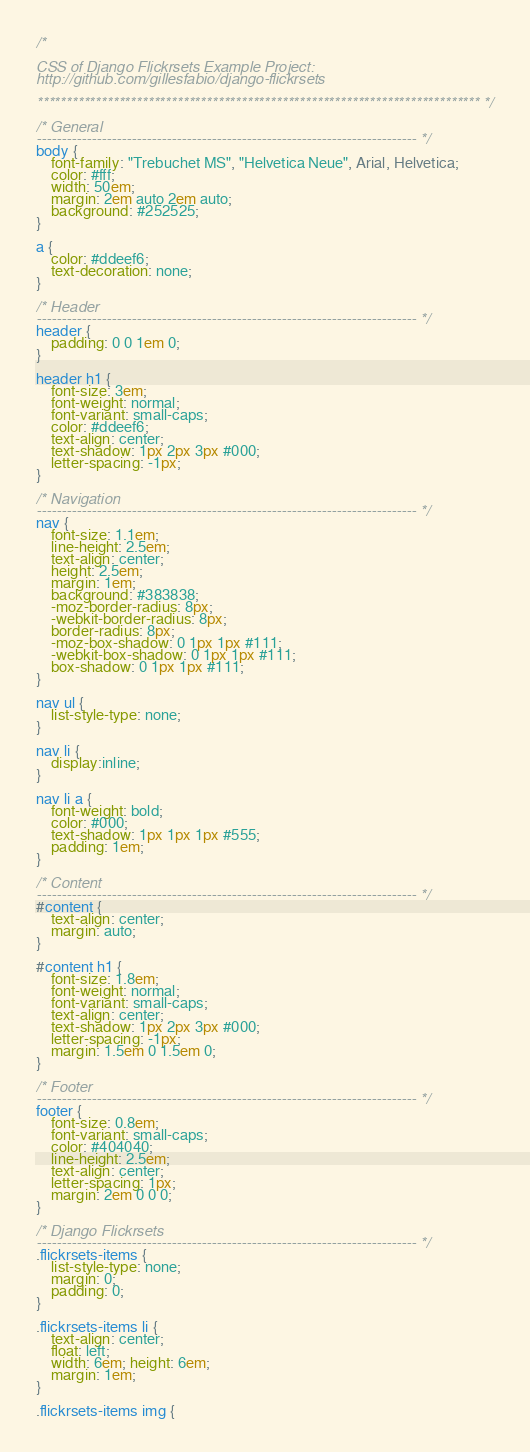<code> <loc_0><loc_0><loc_500><loc_500><_CSS_>/* 

CSS of Django Flickrsets Example Project: 
http://github.com/gillesfabio/django-flickrsets

**************************************************************************** */

/* General
---------------------------------------------------------------------------- */
body {
    font-family: "Trebuchet MS", "Helvetica Neue", Arial, Helvetica;
    color: #fff;
    width: 50em;
    margin: 2em auto 2em auto;
    background: #252525;
}

a { 
    color: #ddeef6; 
    text-decoration: none; 
}

/* Header
---------------------------------------------------------------------------- */
header { 
    padding: 0 0 1em 0; 
}

header h1 {
    font-size: 3em;
    font-weight: normal;
    font-variant: small-caps;
    color: #ddeef6;
    text-align: center;
    text-shadow: 1px 2px 3px #000;
    letter-spacing: -1px;
}

/* Navigation
---------------------------------------------------------------------------- */
nav {
    font-size: 1.1em;
    line-height: 2.5em;
    text-align: center;
    height: 2.5em;
    margin: 1em;
    background: #383838;
    -moz-border-radius: 8px;
    -webkit-border-radius: 8px;
    border-radius: 8px;
    -moz-box-shadow: 0 1px 1px #111;
    -webkit-box-shadow: 0 1px 1px #111;
    box-shadow: 0 1px 1px #111;
}

nav ul { 
    list-style-type: none; 
}

nav li { 
    display:inline; 
}

nav li a {
    font-weight: bold;
    color: #000;
    text-shadow: 1px 1px 1px #555;
    padding: 1em;
}

/* Content
---------------------------------------------------------------------------- */
#content { 
    text-align: center; 
    margin: auto; 
}

#content h1 {
    font-size: 1.8em;
    font-weight: normal;
    font-variant: small-caps;
    text-align: center;
    text-shadow: 1px 2px 3px #000;
    letter-spacing: -1px;
    margin: 1.5em 0 1.5em 0;
}

/* Footer
---------------------------------------------------------------------------- */
footer {
    font-size: 0.8em;
    font-variant: small-caps;
    color: #404040;
    line-height: 2.5em;
    text-align: center;
    letter-spacing: 1px;
    margin: 2em 0 0 0;
}

/* Django Flickrsets
---------------------------------------------------------------------------- */
.flickrsets-items {
    list-style-type: none;
    margin: 0; 
    padding: 0;
}

.flickrsets-items li {
    text-align: center;
    float: left;
    width: 6em; height: 6em;
    margin: 1em;
} 

.flickrsets-items img {</code> 